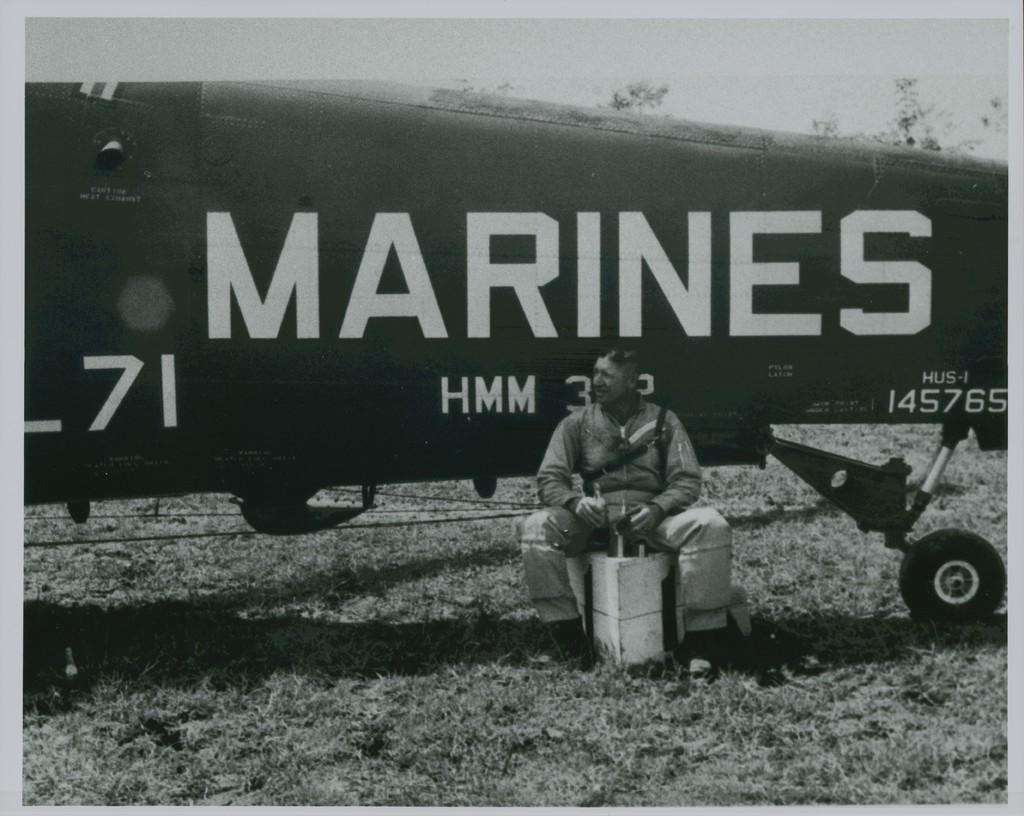<image>
Summarize the visual content of the image. a man was sitting beside a Marine plane long ago 